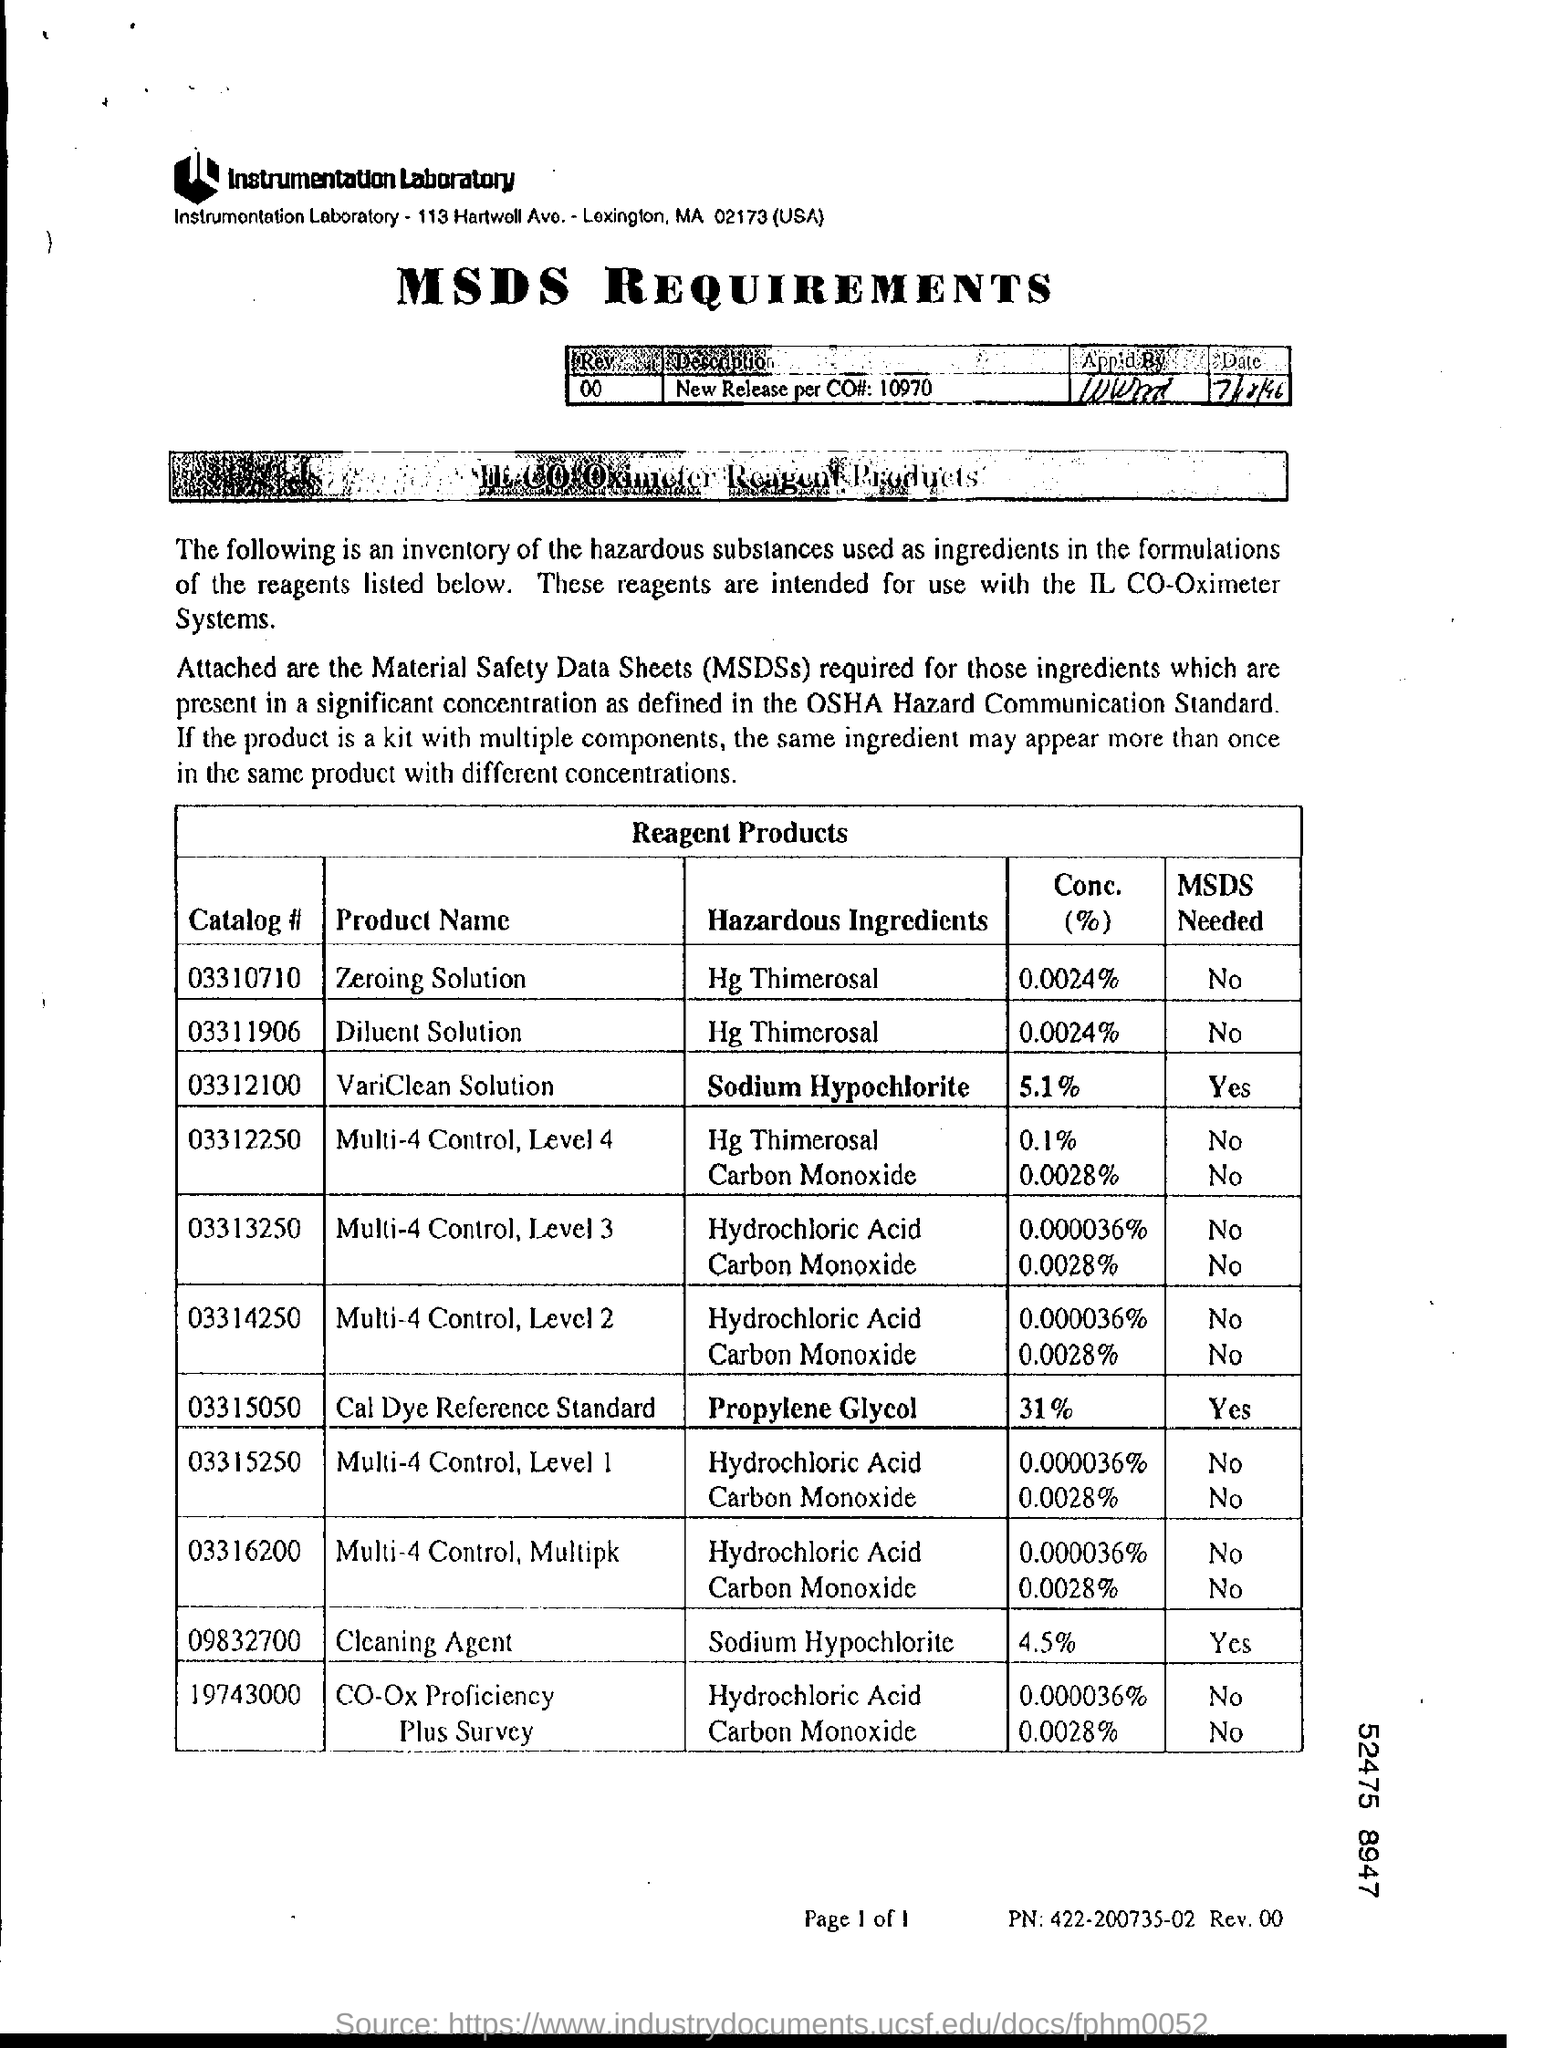Highlight a few significant elements in this photo. The catalog number for the zeroing solution is 03310710. The concentration (%) for the zeroing solution is 0.0024%. The concentration of VariClean solution is 5.1%. Please provide the Catalog Number for the Diluent solution, 03311906... The cleaning agent concentration is 4.5%. 